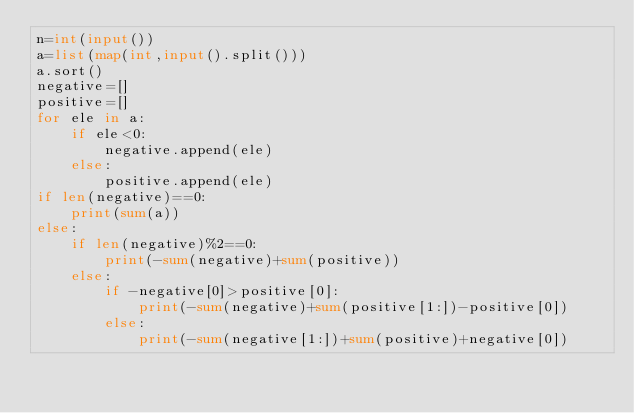<code> <loc_0><loc_0><loc_500><loc_500><_Python_>n=int(input())
a=list(map(int,input().split()))
a.sort()
negative=[]
positive=[]
for ele in a:
    if ele<0:
        negative.append(ele)
    else:
        positive.append(ele)
if len(negative)==0:
    print(sum(a))
else:
    if len(negative)%2==0:
        print(-sum(negative)+sum(positive))
    else:
        if -negative[0]>positive[0]:
            print(-sum(negative)+sum(positive[1:])-positive[0])
        else:
            print(-sum(negative[1:])+sum(positive)+negative[0])


</code> 